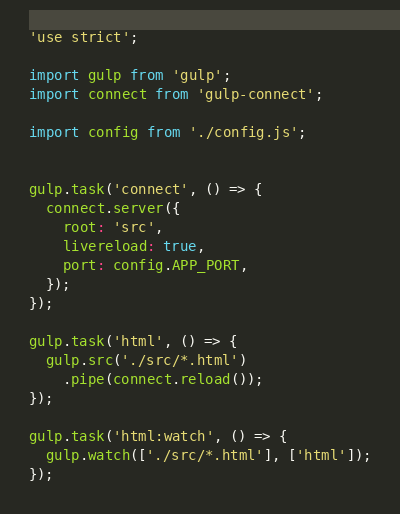Convert code to text. <code><loc_0><loc_0><loc_500><loc_500><_JavaScript_>'use strict';

import gulp from 'gulp';
import connect from 'gulp-connect';

import config from './config.js';


gulp.task('connect', () => {
  connect.server({
    root: 'src',
    livereload: true,
    port: config.APP_PORT,
  });
});

gulp.task('html', () => {
  gulp.src('./src/*.html')
    .pipe(connect.reload());
});

gulp.task('html:watch', () => {
  gulp.watch(['./src/*.html'], ['html']);
});
</code> 